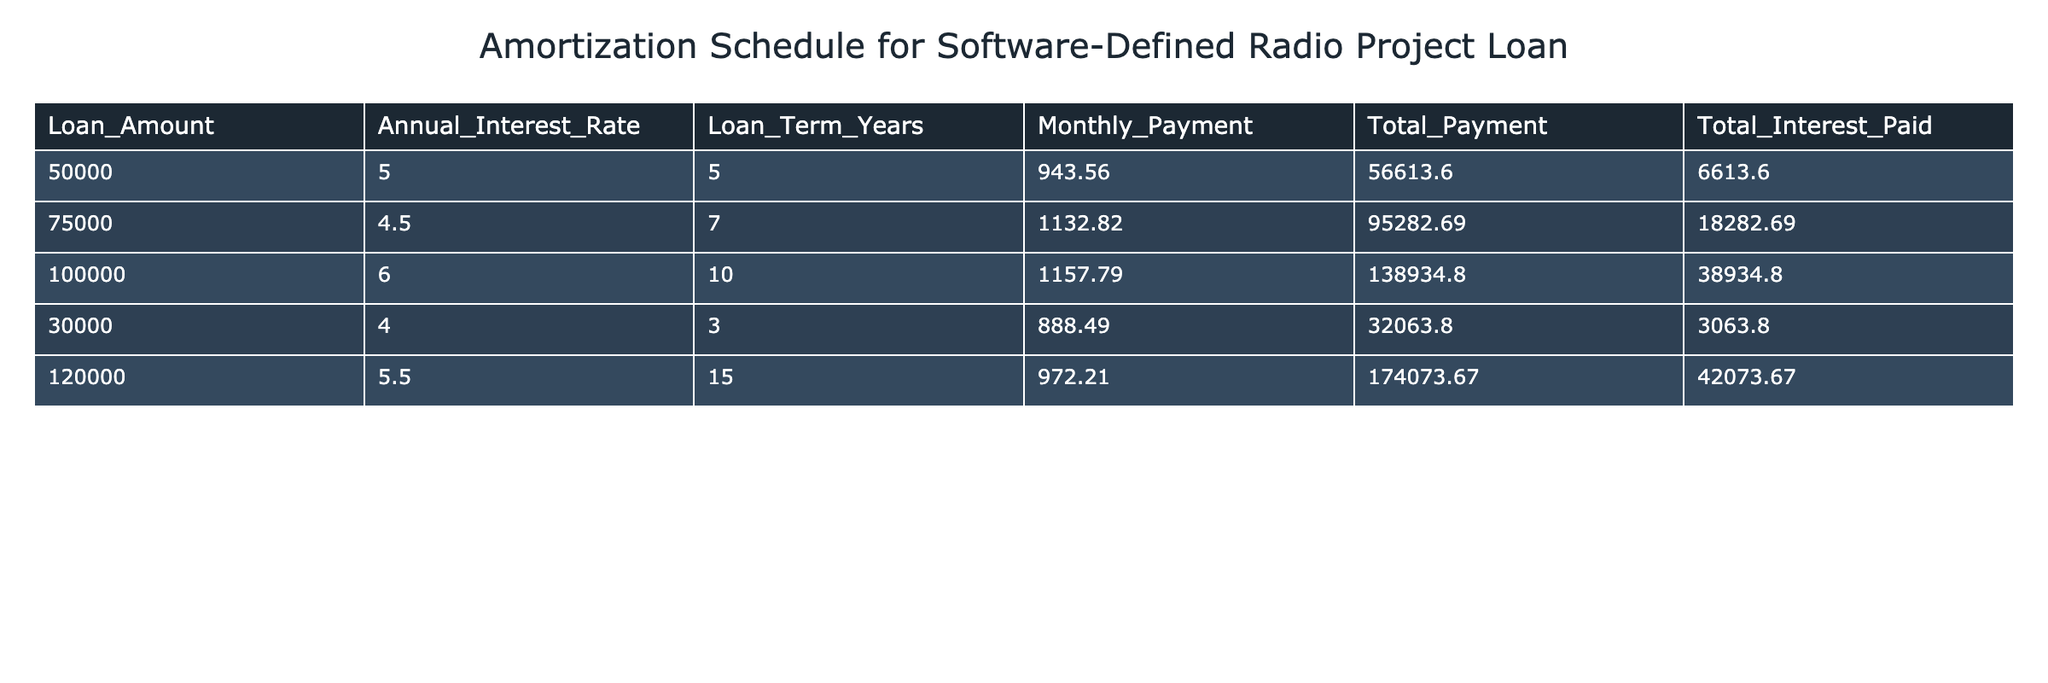What is the largest loan amount in the table? The table lists various loan amounts: 50000, 75000, 100000, 30000, and 120000. The largest value among these is 120000.
Answer: 120000 What is the total interest paid for a loan amount of 50000? The table shows the total interest paid for a loan amount of 50000 as 6613.60. This is directly retrieved from the column labeled "Total Interest Paid".
Answer: 6613.60 Which loan has the highest monthly payment? Comparing the monthly payments: 943.56, 1132.82, 1157.79, 888.49, and 972.21. The highest among them is 1157.79, corresponding to the 100000 loan with a 10-year term.
Answer: 1157.79 What is the difference in total payments between the highest and lowest loan amounts? The highest total payment is 174073.67 (for the 120000 loan) and the lowest is 32063.80 (for the 30000 loan). The difference is 174073.67 - 32063.80 = 141009.87.
Answer: 141009.87 Is the annual interest rate for the loan amount of 75000 higher than that for the loan amount of 30000? The annual interest rate for 75000 is 4.5, while for the loan of 30000, it is 4. Therefore, 4.5 is indeed higher than 4.
Answer: Yes What is the average total interest paid across all loans? The total interest paid values are: 6613.60, 18282.69, 38934.80, 3063.80, and 42073.67. Summing these gives 6613.60 + 18282.69 + 38934.80 + 3063.80 + 42073.67 = 109068.56. Dividing by the number of loans (5) yields an average of 109068.56 / 5 = 21813.71.
Answer: 21813.71 Which loan term corresponds to the loan amount of 120000? The table shows that the loan amount of 120000 has a loan term of 15 years, which is presented in the "Loan Term Years" column.
Answer: 15 What was the total payment for the loan with the lowest monthly payment? The lowest monthly payment is 888.49, which corresponds to the loan amount of 30000. The total payment for this loan is 32063.80, retrieved from the "Total Payment" column.
Answer: 32063.80 Which loan had the highest interest rate? Reviewing the annual interest rates: 5, 4.5, 6, 4, and 5.5, the highest rate is 6, which corresponds to the loan amount of 100000.
Answer: 6 